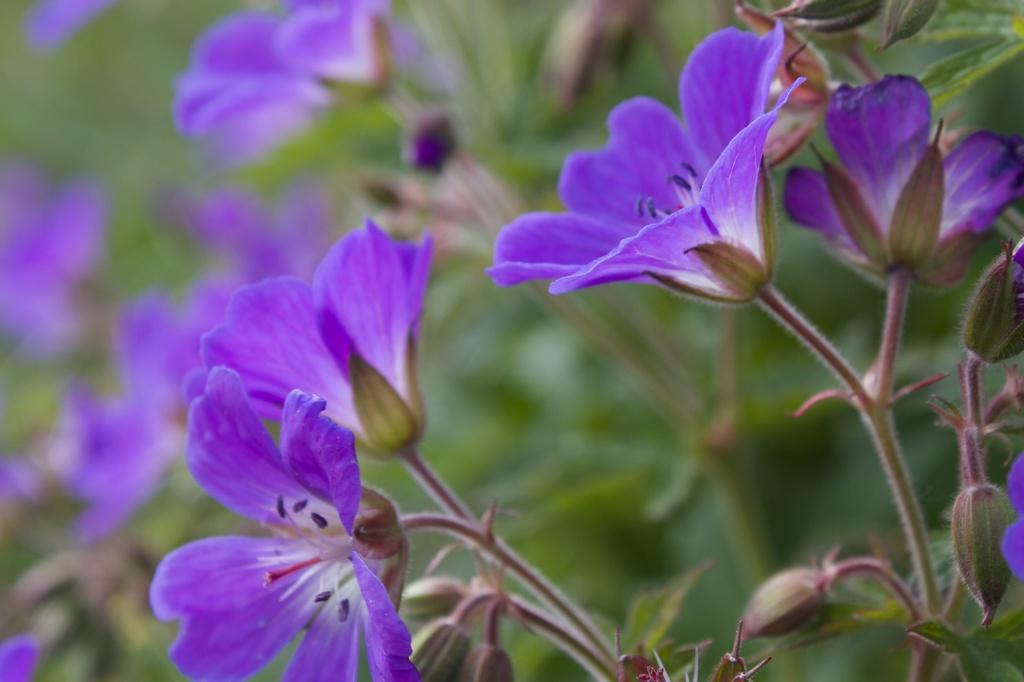What types of living organisms can be seen in the image? The image contains flowers and plants. Can you describe the background of the image? The background of the image is blurred. What type of cushion can be seen in the image? There is no cushion present in the image. Are there any cobwebs visible in the image? There are no cobwebs visible in the image. 